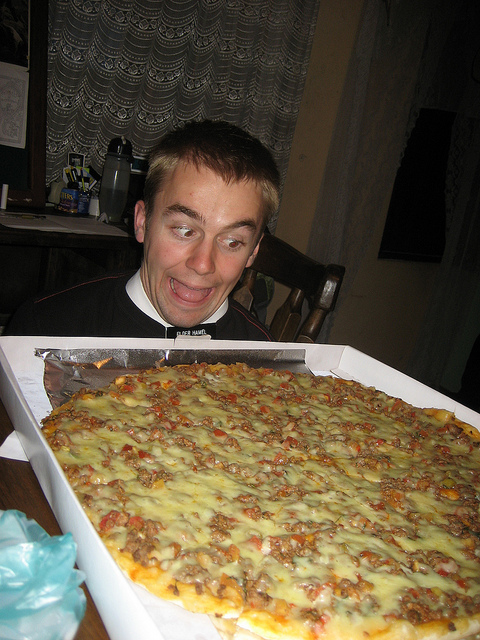<image>What gender is the kid? It is unclear what gender the kid is. However, it can be seen male. What gender is the kid? I don't know the gender of the kid. But it can be seen male. 